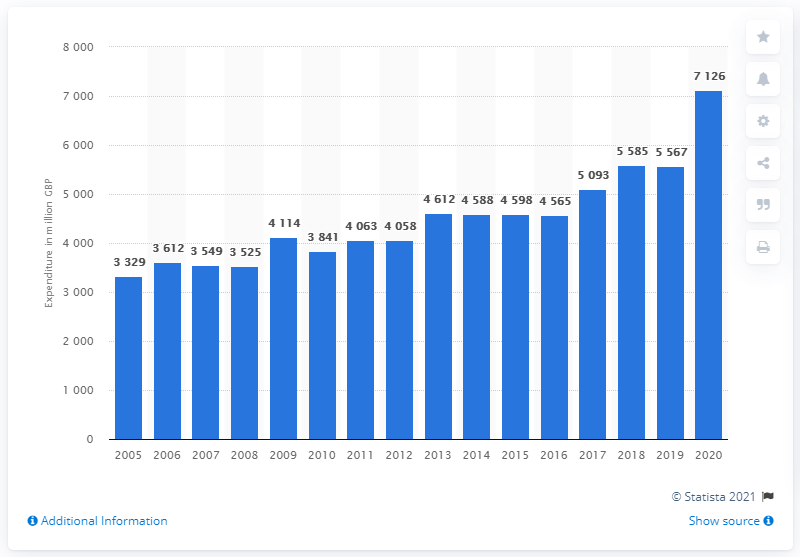Give some essential details in this illustration. Spending has generally grown since 2010. In the year 2020, British consumers spent a total of 7,126 pounds on beer. In the UK, consumers have spent more than 7.1 billion pounds on beer. This was the last time this amount of money was spent on beer. 